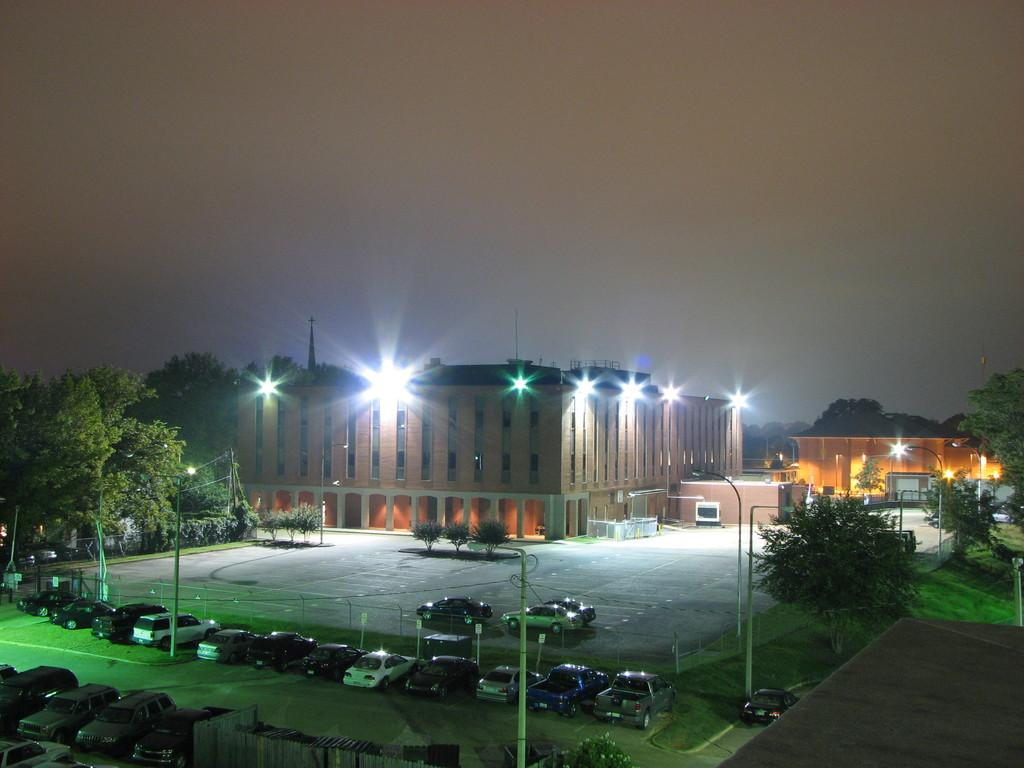What can be seen in the foreground of the image? There are many cars parked in the foreground of the image. What is visible in the background of the image? There are buildings, trees, and lights in the background of the image. What is the condition of the sky in the image? The sky is clear in the image. Can you tell me how many rats are sitting on the book in the image? There are no rats or books present in the image. What type of trade is being conducted in the image? There is no trade being conducted in the image; it primarily features parked cars and background elements. 